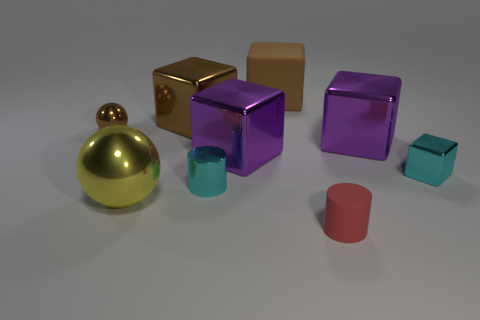If the objects in the image were part of a collection, what could be the theme? If these objects were a part of a collection, the theme could revolve around 'Geometric Shapes and Reflections'. Each object showcases a distinct geometric shape along with reflective surfaces that interact uniquely with the light, creating an exhibition of form and luminosity. 